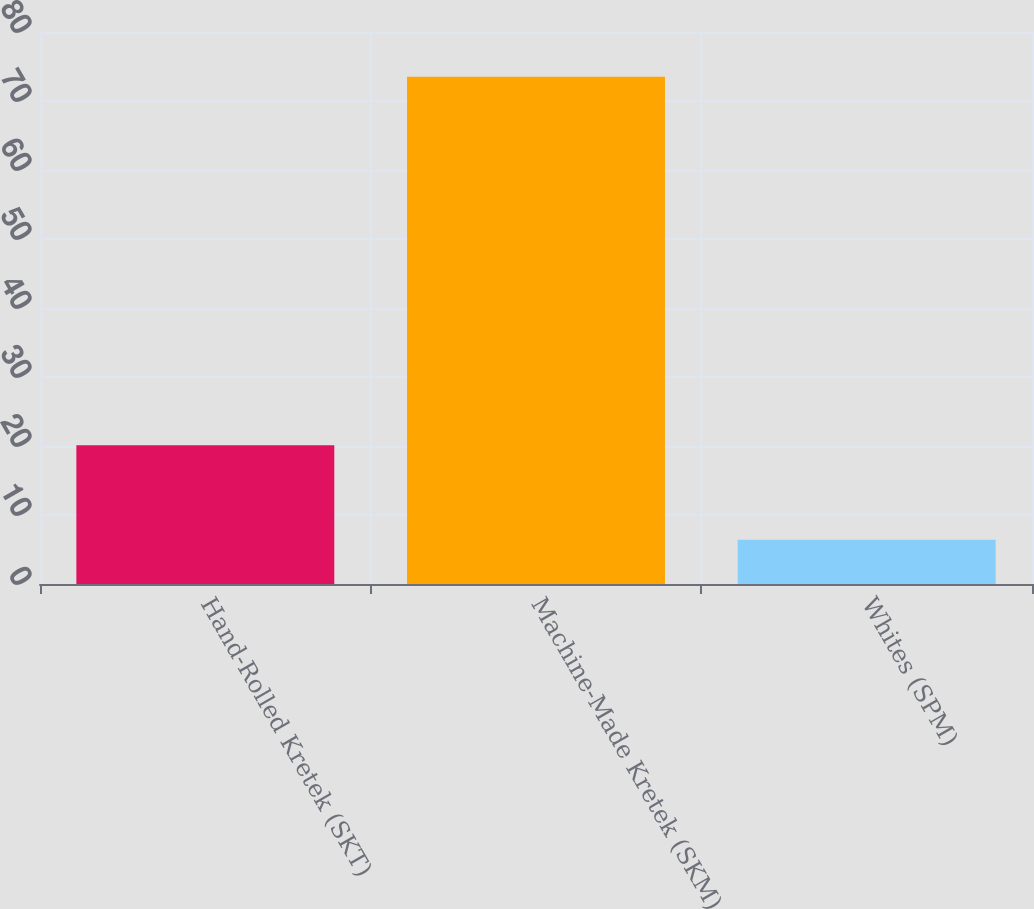Convert chart to OTSL. <chart><loc_0><loc_0><loc_500><loc_500><bar_chart><fcel>Hand-Rolled Kretek (SKT)<fcel>Machine-Made Kretek (SKM)<fcel>Whites (SPM)<nl><fcel>20.1<fcel>73.5<fcel>6.4<nl></chart> 